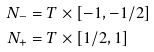Convert formula to latex. <formula><loc_0><loc_0><loc_500><loc_500>N _ { - } & = T \times [ - 1 , - 1 / 2 ] \\ N _ { + } & = T \times [ 1 / 2 , 1 ]</formula> 